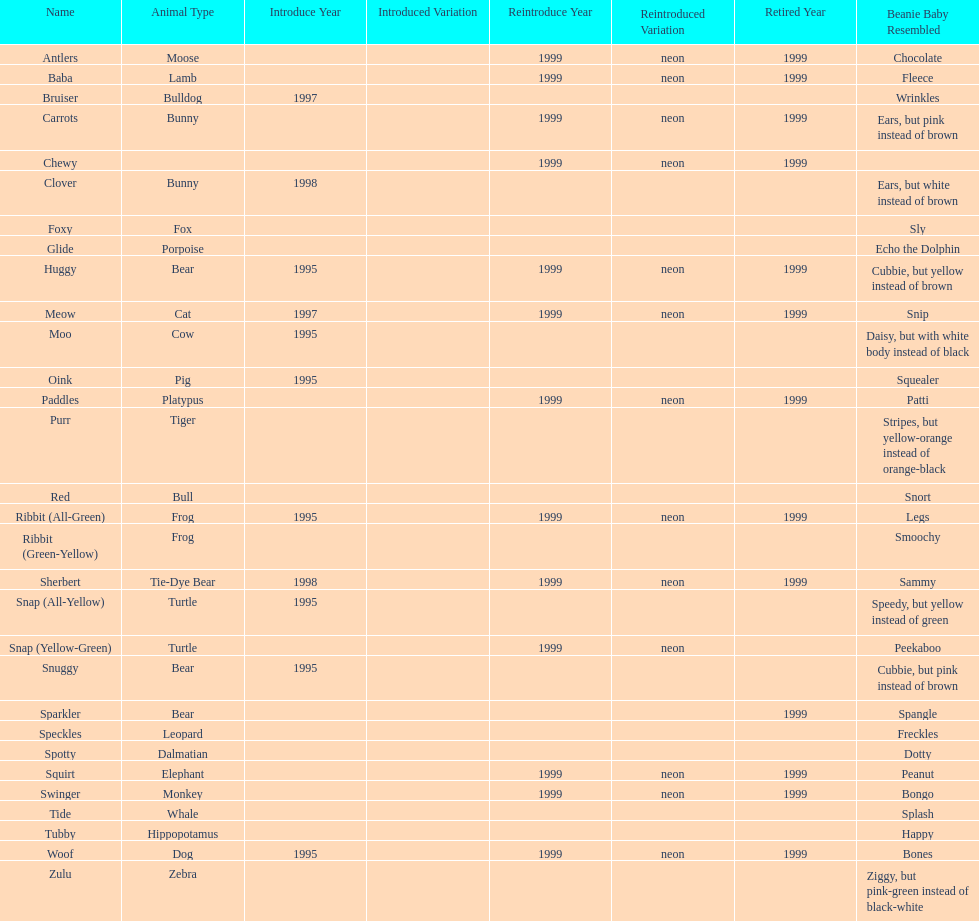How long was woof the dog sold before it was retired? 4 years. 